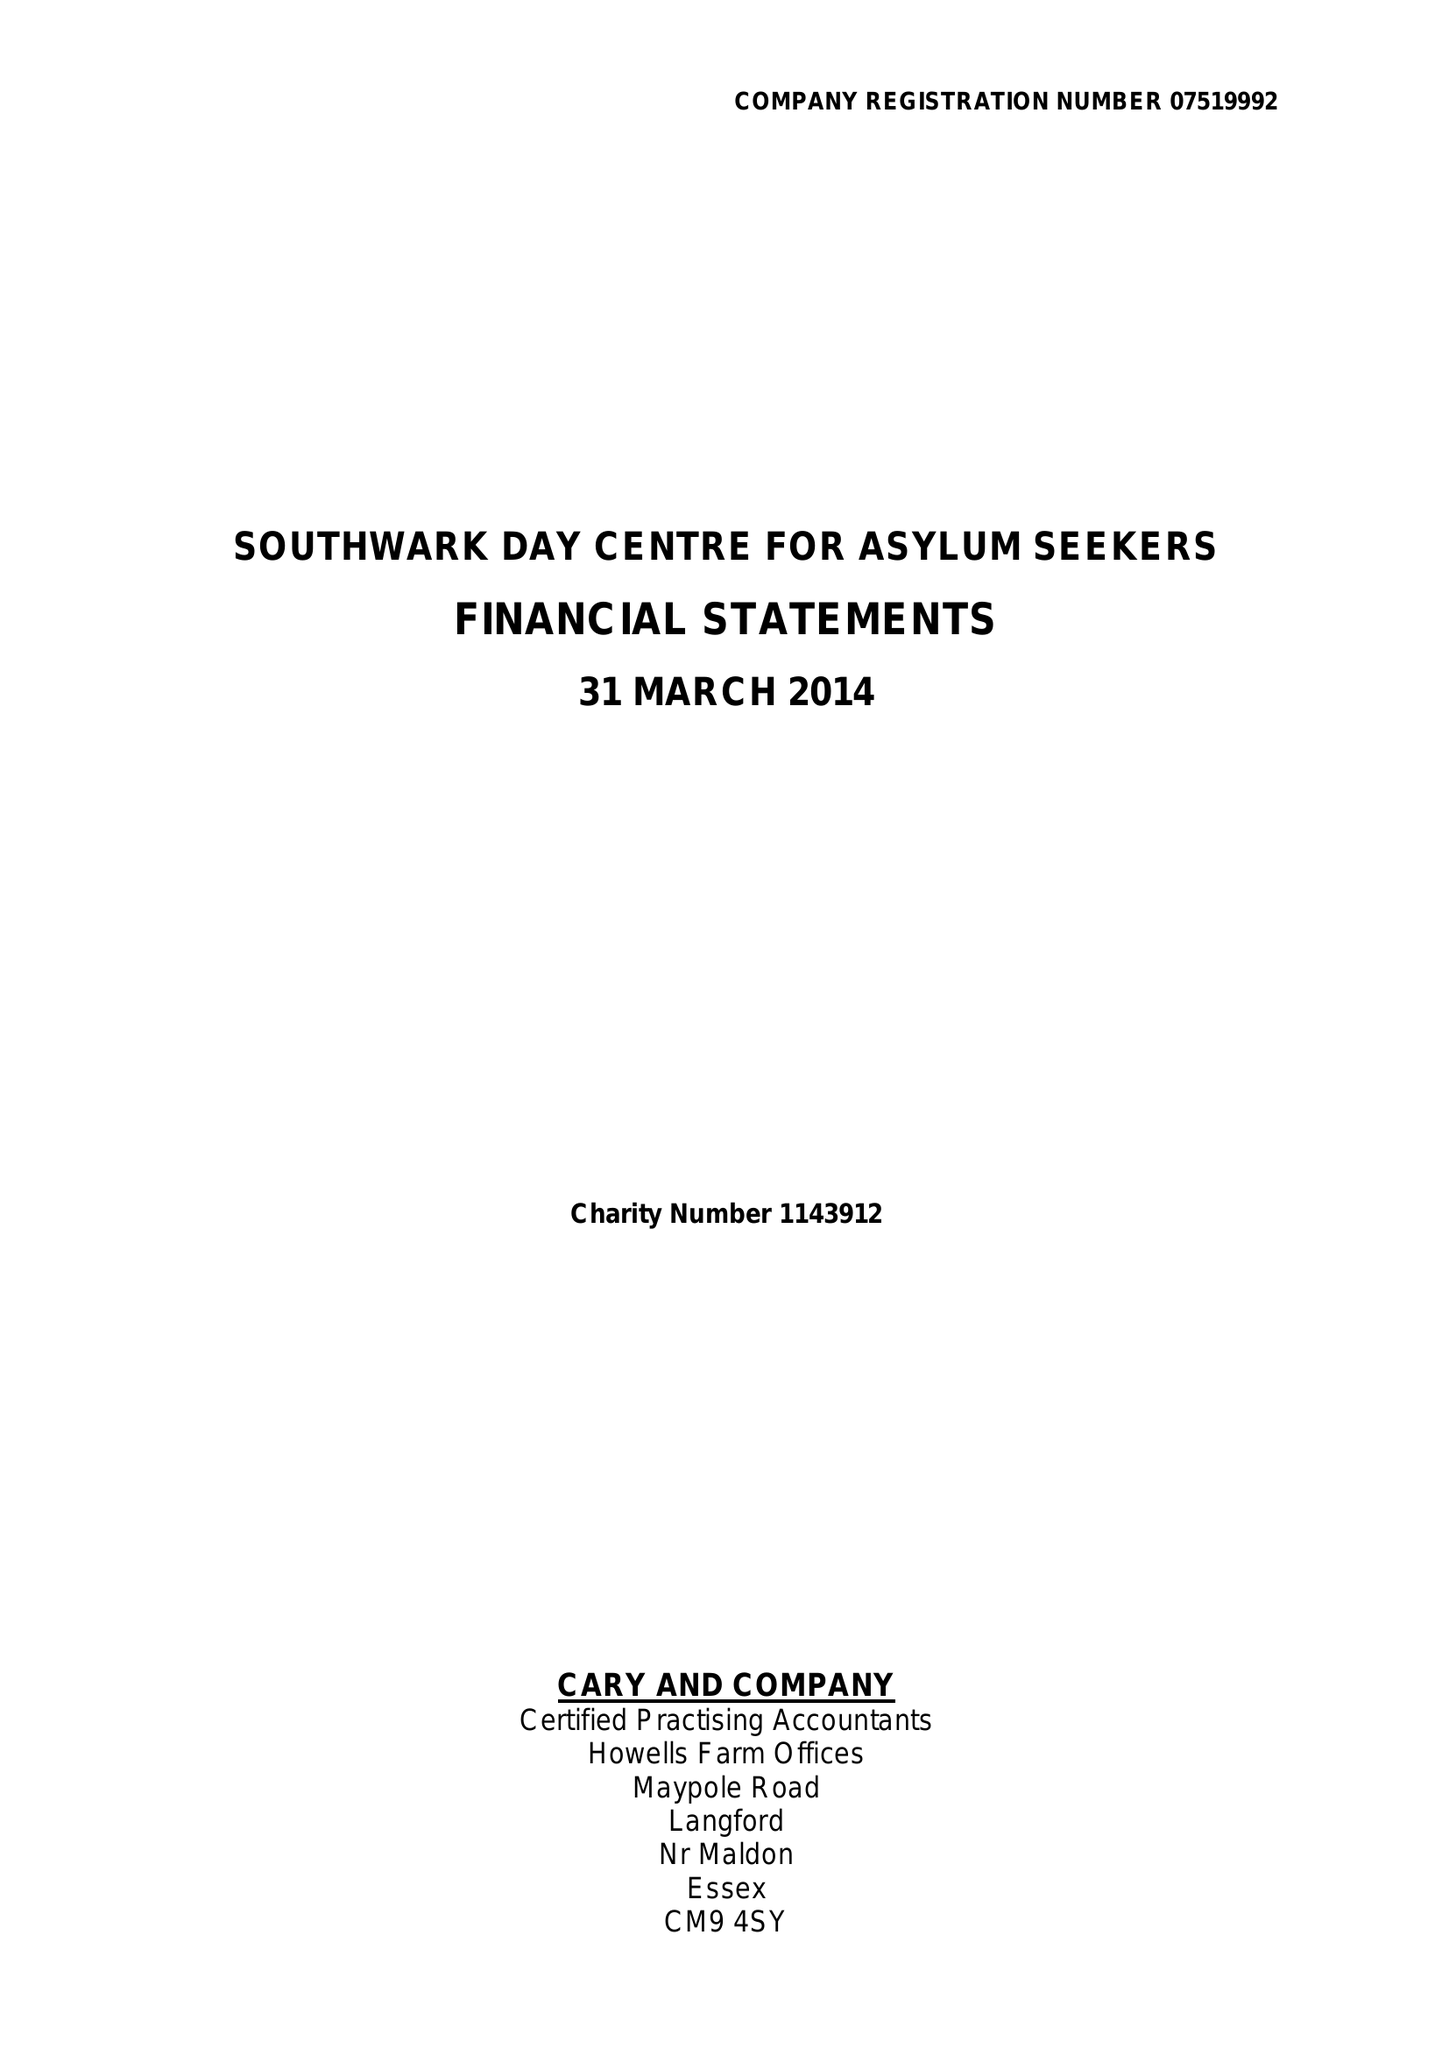What is the value for the charity_number?
Answer the question using a single word or phrase. 1143912 